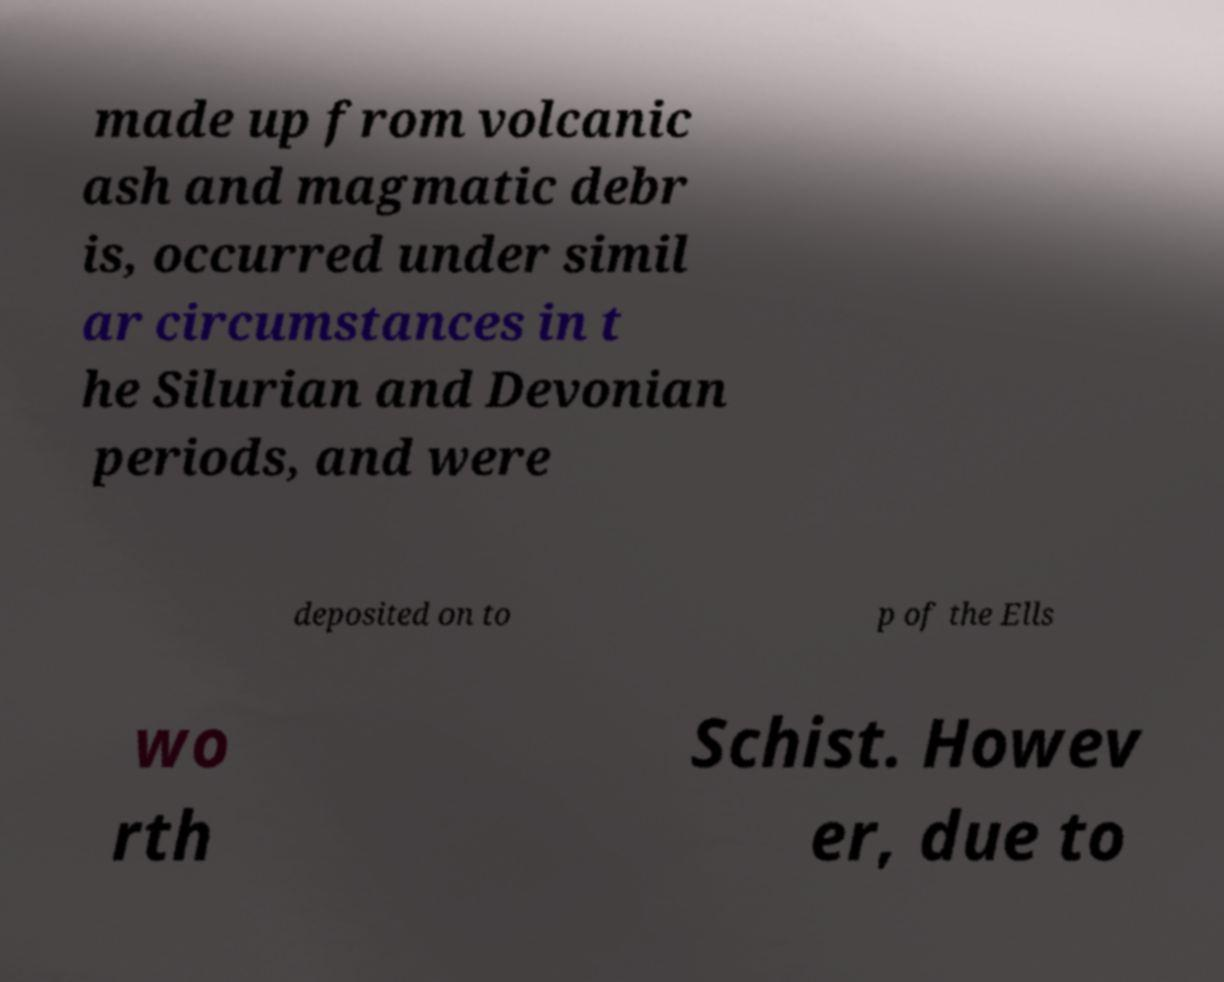Please identify and transcribe the text found in this image. made up from volcanic ash and magmatic debr is, occurred under simil ar circumstances in t he Silurian and Devonian periods, and were deposited on to p of the Ells wo rth Schist. Howev er, due to 